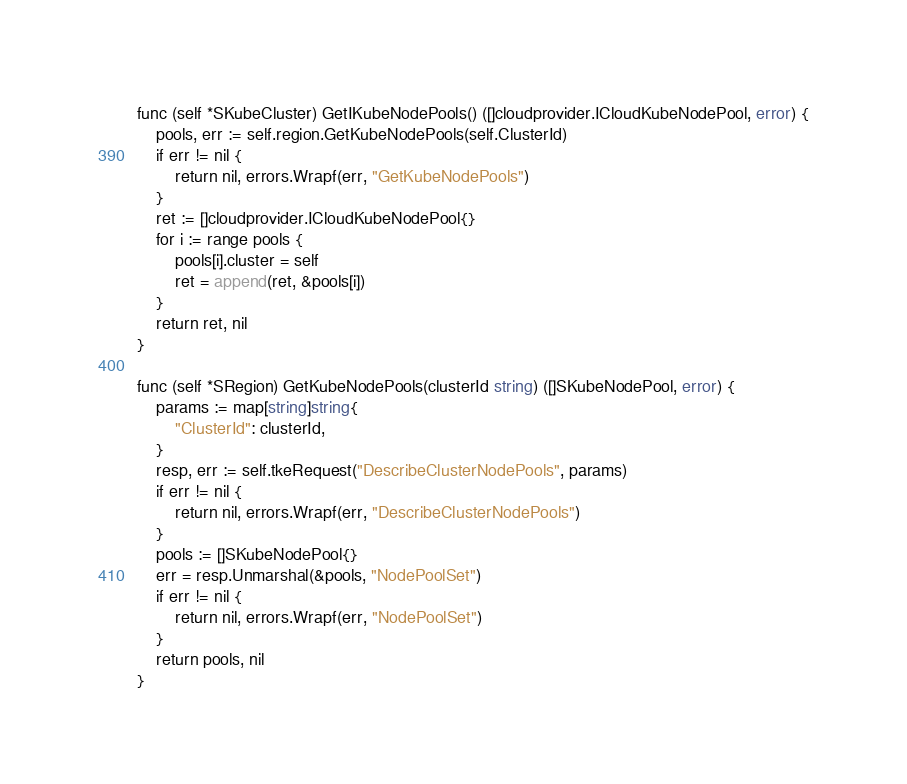<code> <loc_0><loc_0><loc_500><loc_500><_Go_>
func (self *SKubeCluster) GetIKubeNodePools() ([]cloudprovider.ICloudKubeNodePool, error) {
	pools, err := self.region.GetKubeNodePools(self.ClusterId)
	if err != nil {
		return nil, errors.Wrapf(err, "GetKubeNodePools")
	}
	ret := []cloudprovider.ICloudKubeNodePool{}
	for i := range pools {
		pools[i].cluster = self
		ret = append(ret, &pools[i])
	}
	return ret, nil
}

func (self *SRegion) GetKubeNodePools(clusterId string) ([]SKubeNodePool, error) {
	params := map[string]string{
		"ClusterId": clusterId,
	}
	resp, err := self.tkeRequest("DescribeClusterNodePools", params)
	if err != nil {
		return nil, errors.Wrapf(err, "DescribeClusterNodePools")
	}
	pools := []SKubeNodePool{}
	err = resp.Unmarshal(&pools, "NodePoolSet")
	if err != nil {
		return nil, errors.Wrapf(err, "NodePoolSet")
	}
	return pools, nil
}
</code> 